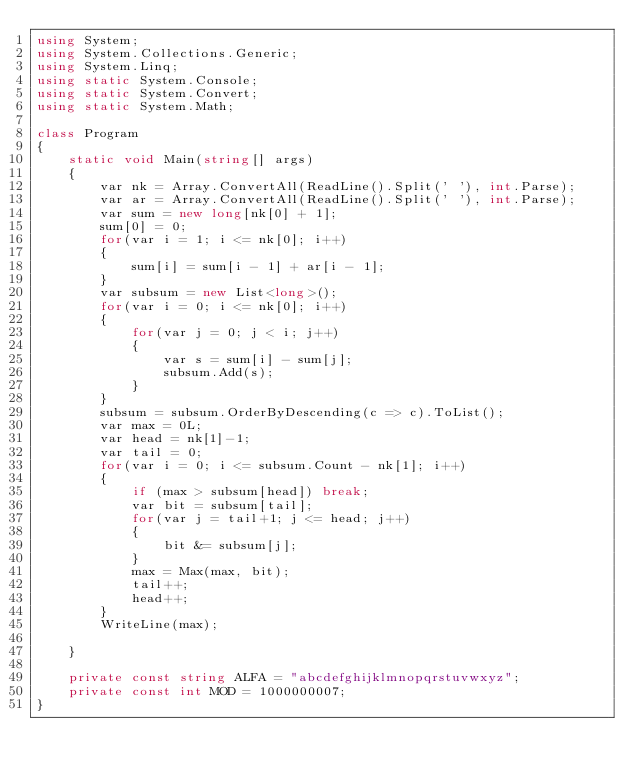Convert code to text. <code><loc_0><loc_0><loc_500><loc_500><_C#_>using System;
using System.Collections.Generic;
using System.Linq;
using static System.Console;
using static System.Convert;
using static System.Math;

class Program
{
    static void Main(string[] args)
    {
        var nk = Array.ConvertAll(ReadLine().Split(' '), int.Parse);
        var ar = Array.ConvertAll(ReadLine().Split(' '), int.Parse);
        var sum = new long[nk[0] + 1];
        sum[0] = 0;
        for(var i = 1; i <= nk[0]; i++)
        {
            sum[i] = sum[i - 1] + ar[i - 1];
        }
        var subsum = new List<long>();
        for(var i = 0; i <= nk[0]; i++)
        {
            for(var j = 0; j < i; j++)
            {
                var s = sum[i] - sum[j];
                subsum.Add(s);
            }
        }
        subsum = subsum.OrderByDescending(c => c).ToList();
        var max = 0L;
        var head = nk[1]-1;
        var tail = 0;
        for(var i = 0; i <= subsum.Count - nk[1]; i++)
        {
            if (max > subsum[head]) break;
            var bit = subsum[tail];
            for(var j = tail+1; j <= head; j++)
            {
                bit &= subsum[j];
            }
            max = Max(max, bit);
            tail++;
            head++;
        }
        WriteLine(max);
        
    }

    private const string ALFA = "abcdefghijklmnopqrstuvwxyz";
    private const int MOD = 1000000007;
}
</code> 